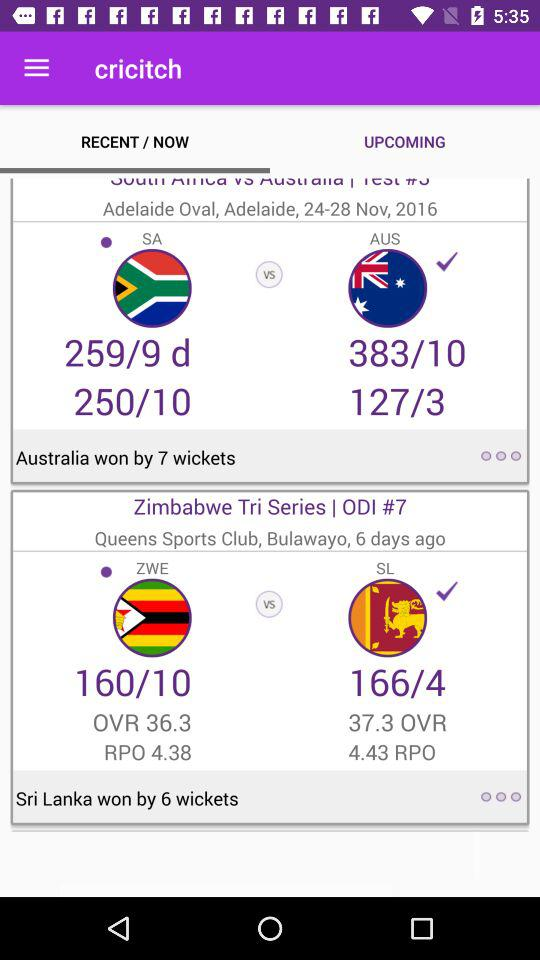By how many wickets did Australia win? Australia won by 7 wickets. 